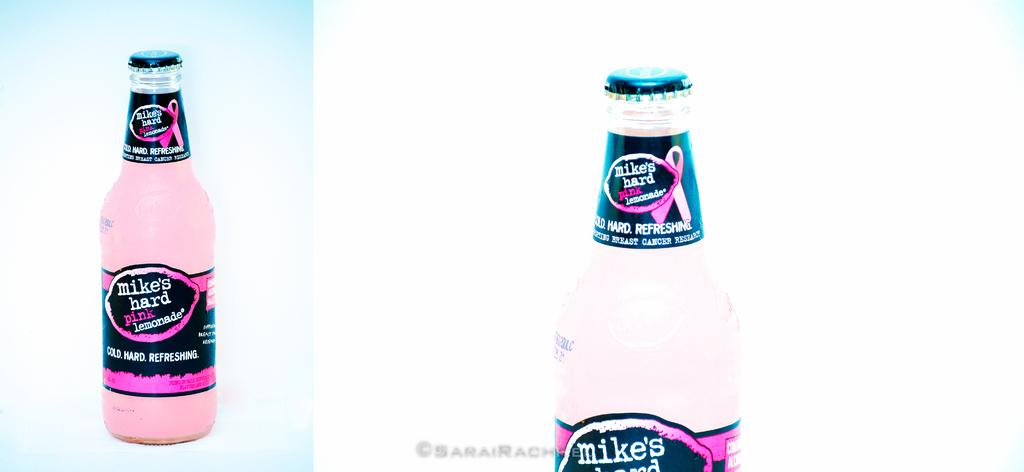<image>
Render a clear and concise summary of the photo. a bottle of pink liquid reading 'Mike's hard pink lemonade' 